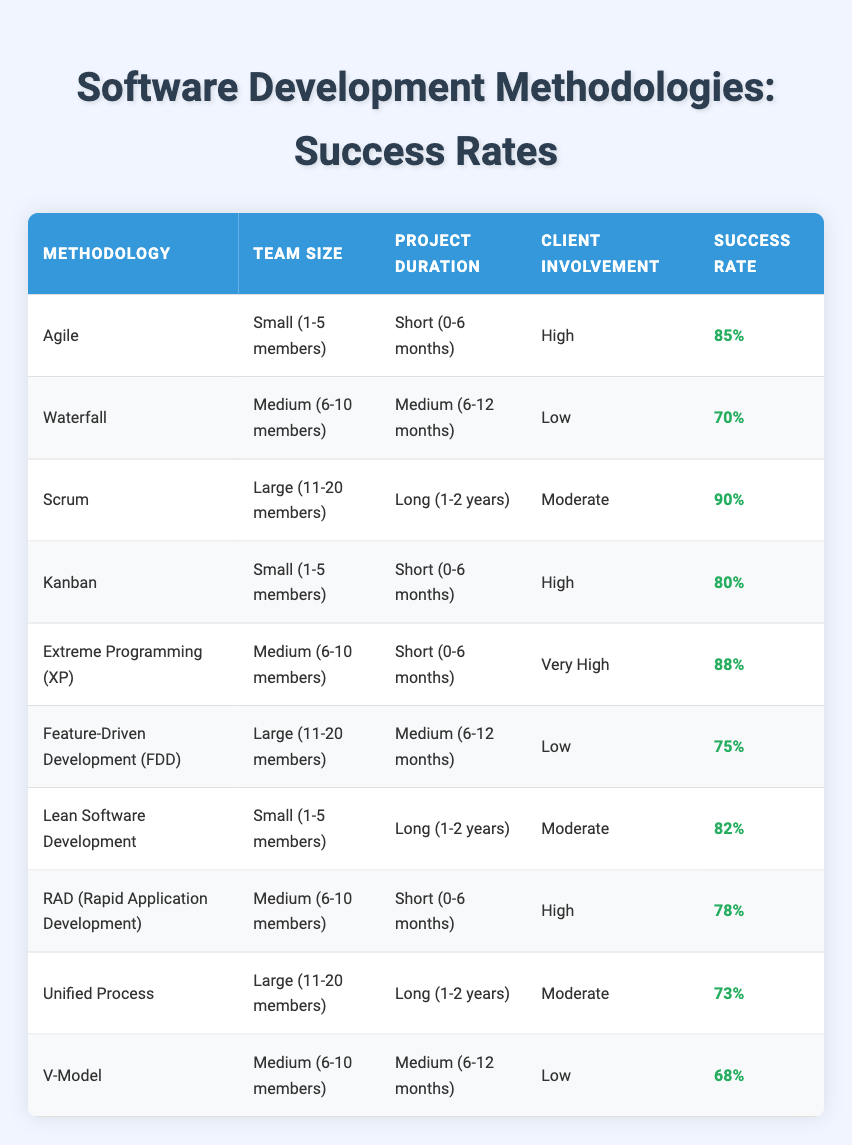What is the success rate of the Scrum methodology? The Scrum methodology has a listed success rate of 90% in the table.
Answer: 90% How many methodologies use a team size categorized as "Small (1-5 members)"? There are three methodologies that use this team size (Agile, Kanban, and Lean Software Development).
Answer: 3 Which methodology has the highest success rate? The Scrum methodology, with a success rate of 90%, has the highest rate compared to the others in the table.
Answer: Scrum What is the average success rate of methodologies with "Medium (6-10 members)" team sizes? The success rates for the methodologies with "Medium (6-10 members)" are 70%, 88%, 78%, and 68%. Adding these gives 70 + 88 + 78 + 68 = 304, and dividing by 4 gives an average success rate of 76%.
Answer: 76% Is the success rate of Kanban greater than that of Waterfall? Yes, the success rate of Kanban (80%) is greater than that of Waterfall (70%).
Answer: Yes Which project duration is associated with the lowest success rate? Looking at the table, the V-Model has the lowest success rate of 68%, which falls under the "Medium (6-12 months)" project duration.
Answer: Medium (6-12 months) How does the success rate of methodologies with "High" client involvement compare to those with "Low" involvement? The success rates for methodologies with "High" client involvement are 85% (Agile) and 80% (Kanban), totaling 165%. For "Low" involvement, the success rates are 70% (Waterfall), 75% (FDD), and 68% (V-Model), totaling 213%. The average for "High" is 82.5% and "Low" is 71%. So "High" involvement has a higher average success rate than "Low" involvement.
Answer: High involvement is higher What is the total number of methodologies listed in the table? The table shows a total of 10 distinct software development methodologies.
Answer: 10 What is the success rate of the Extreme Programming (XP) methodology compared to the Lean Software Development method? Extreme Programming (XP) has a success rate of 88%, while Lean Software Development has a success rate of 82%. Thus, XP's success rate is higher by 6%.
Answer: Extreme Programming (XP) is higher 